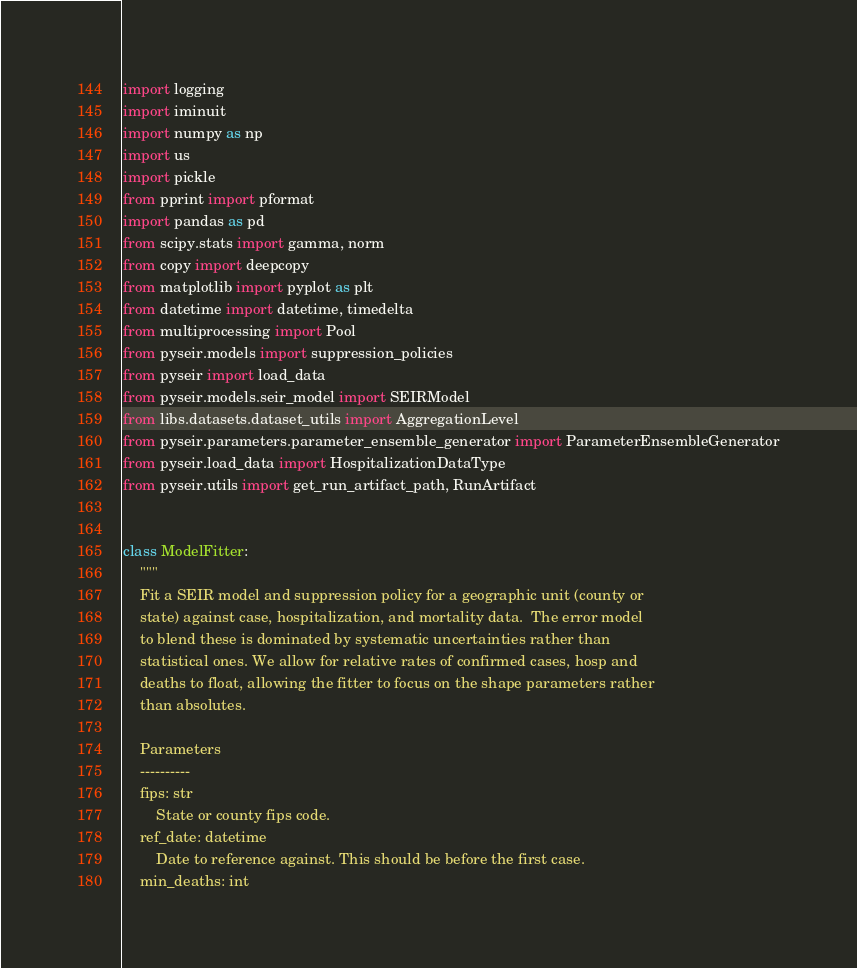Convert code to text. <code><loc_0><loc_0><loc_500><loc_500><_Python_>import logging
import iminuit
import numpy as np
import us
import pickle
from pprint import pformat
import pandas as pd
from scipy.stats import gamma, norm
from copy import deepcopy
from matplotlib import pyplot as plt
from datetime import datetime, timedelta
from multiprocessing import Pool
from pyseir.models import suppression_policies
from pyseir import load_data
from pyseir.models.seir_model import SEIRModel
from libs.datasets.dataset_utils import AggregationLevel
from pyseir.parameters.parameter_ensemble_generator import ParameterEnsembleGenerator
from pyseir.load_data import HospitalizationDataType
from pyseir.utils import get_run_artifact_path, RunArtifact


class ModelFitter:
    """
    Fit a SEIR model and suppression policy for a geographic unit (county or
    state) against case, hospitalization, and mortality data.  The error model
    to blend these is dominated by systematic uncertainties rather than
    statistical ones. We allow for relative rates of confirmed cases, hosp and
    deaths to float, allowing the fitter to focus on the shape parameters rather
    than absolutes.

    Parameters
    ----------
    fips: str
        State or county fips code.
    ref_date: datetime
        Date to reference against. This should be before the first case.
    min_deaths: int</code> 